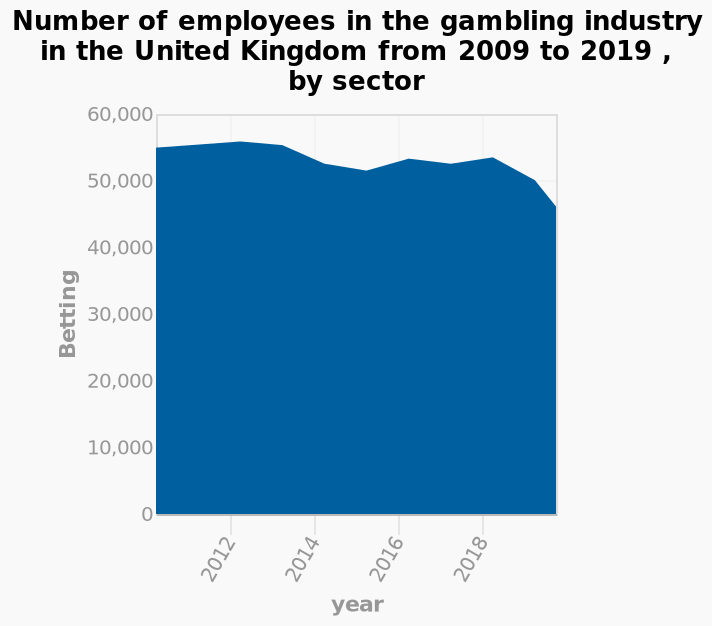<image>
Describe the following image in detail This is a area chart called Number of employees in the gambling industry in the United Kingdom from 2009 to 2019 , by sector. The x-axis shows year while the y-axis plots Betting. What are the increments on the y-axis? The increments on the y-axis are in intervals of 10,000 employees. What does the y-axis plot in the area chart? The y-axis in the area chart plots the number of employees in the gambling industry. 